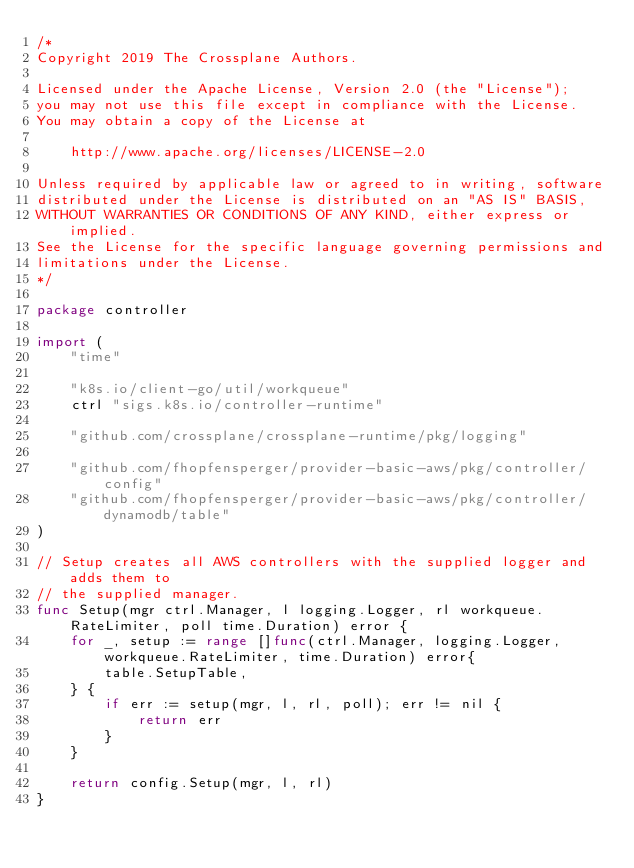<code> <loc_0><loc_0><loc_500><loc_500><_Go_>/*
Copyright 2019 The Crossplane Authors.

Licensed under the Apache License, Version 2.0 (the "License");
you may not use this file except in compliance with the License.
You may obtain a copy of the License at

    http://www.apache.org/licenses/LICENSE-2.0

Unless required by applicable law or agreed to in writing, software
distributed under the License is distributed on an "AS IS" BASIS,
WITHOUT WARRANTIES OR CONDITIONS OF ANY KIND, either express or implied.
See the License for the specific language governing permissions and
limitations under the License.
*/

package controller

import (
	"time"

	"k8s.io/client-go/util/workqueue"
	ctrl "sigs.k8s.io/controller-runtime"

	"github.com/crossplane/crossplane-runtime/pkg/logging"

	"github.com/fhopfensperger/provider-basic-aws/pkg/controller/config"
	"github.com/fhopfensperger/provider-basic-aws/pkg/controller/dynamodb/table"
)

// Setup creates all AWS controllers with the supplied logger and adds them to
// the supplied manager.
func Setup(mgr ctrl.Manager, l logging.Logger, rl workqueue.RateLimiter, poll time.Duration) error {
	for _, setup := range []func(ctrl.Manager, logging.Logger, workqueue.RateLimiter, time.Duration) error{
		table.SetupTable,
	} {
		if err := setup(mgr, l, rl, poll); err != nil {
			return err
		}
	}

	return config.Setup(mgr, l, rl)
}
</code> 